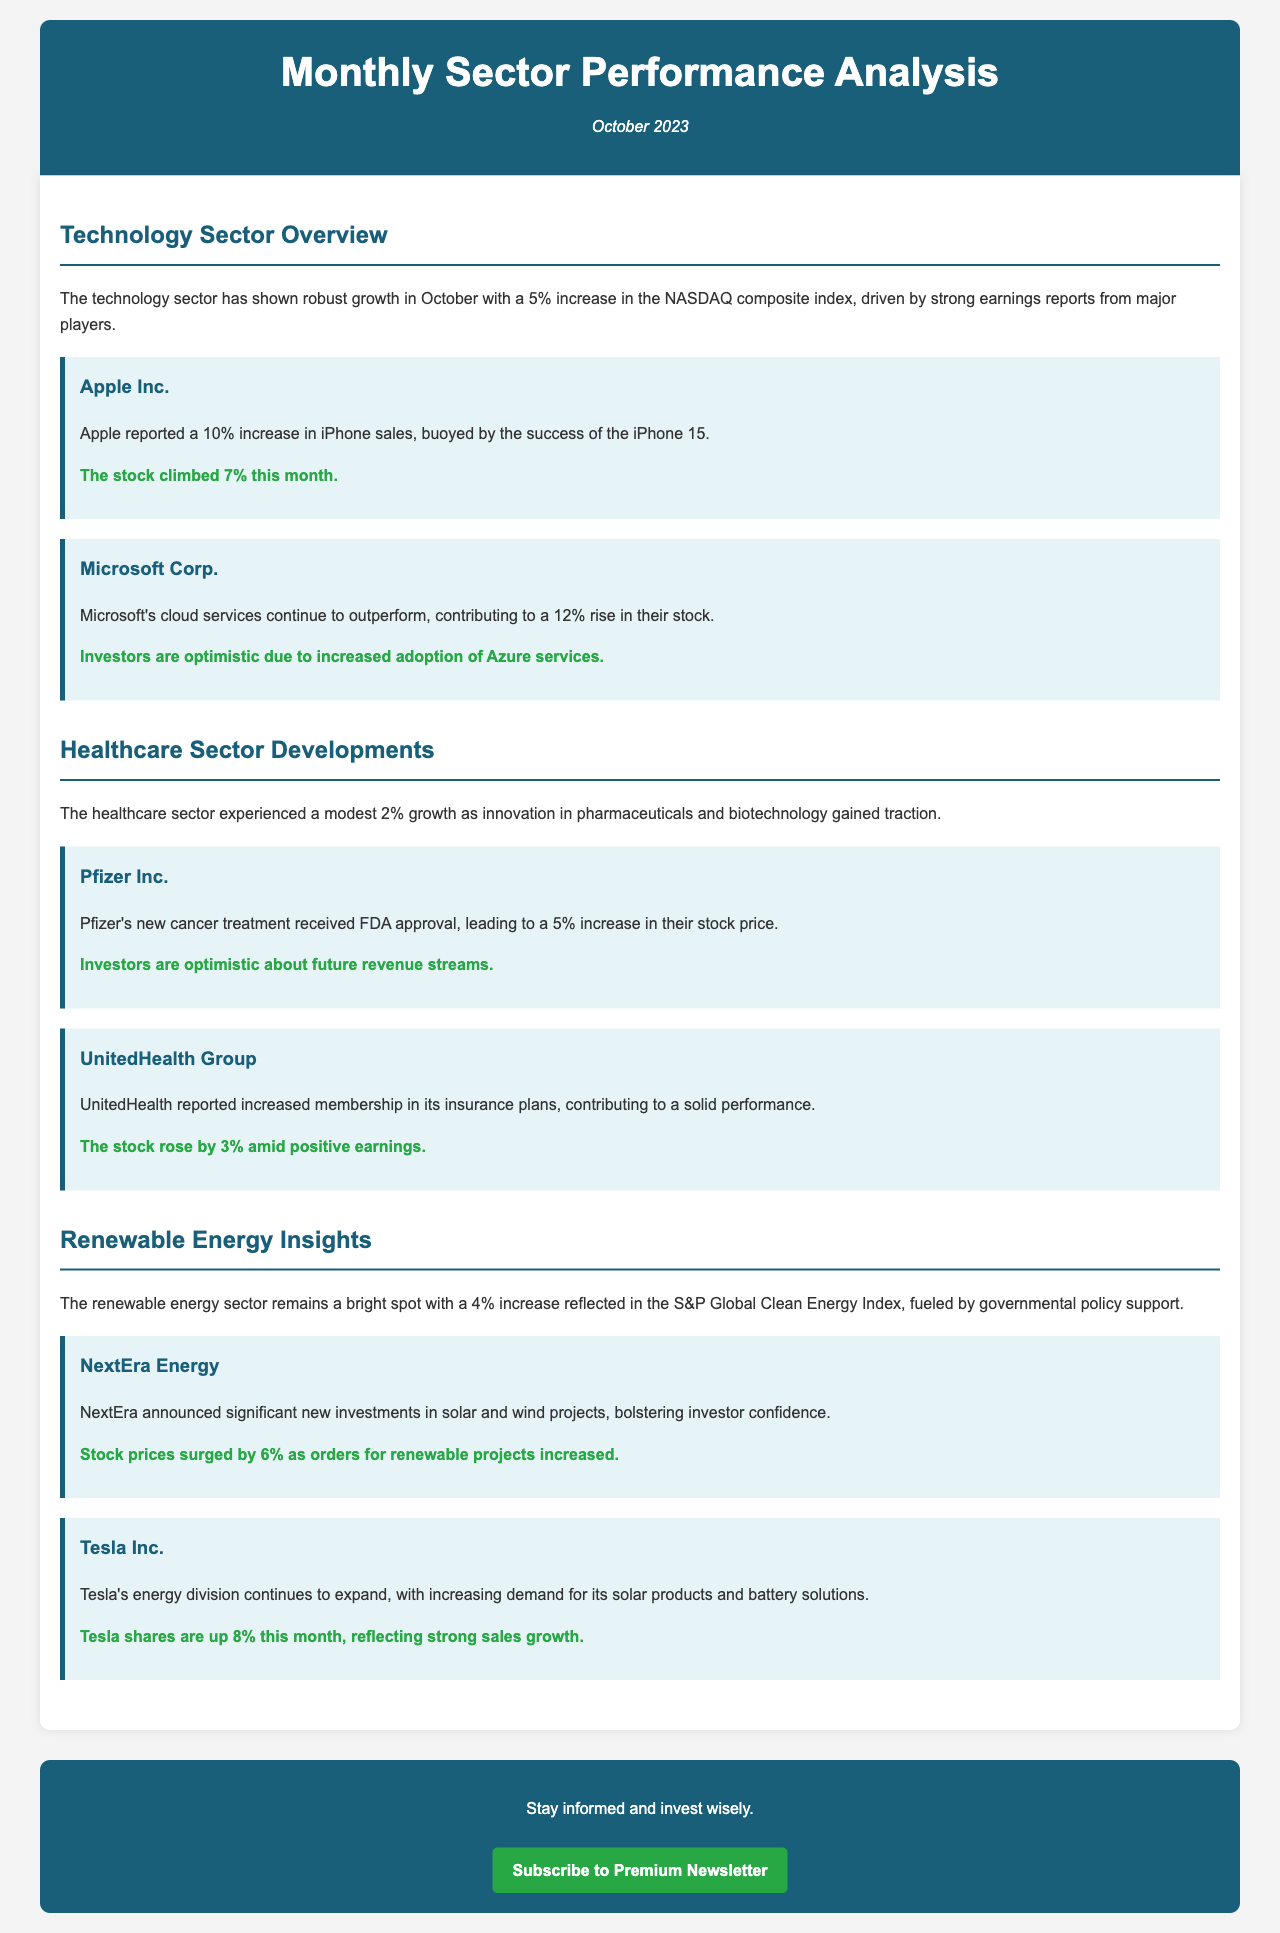What is the increase in the NASDAQ composite index for October? The document states that the technology sector saw a 5% increase in the NASDAQ composite index in October.
Answer: 5% Which company's stock rose by 7% this month? The newsletter indicates that Apple Inc.'s stock climbed 7% this month.
Answer: Apple Inc What percentage increase did Pfizer's stock experience? The document notes a 5% increase in Pfizer's stock price following FDA approval for a new treatment.
Answer: 5% What is NextEra Energy's stock price increase this month? The document highlights a 6% surge in stock prices for NextEra Energy.
Answer: 6% Which healthcare company reported increased membership in its insurance plans? The newsletter mentions that UnitedHealth Group reported increased membership in its insurance plans.
Answer: UnitedHealth Group What is the primary factor driving the growth in the renewable energy sector? The document points out that governmental policy support is fueling growth in the renewable energy sector.
Answer: Governmental policy support What was the increase in stock price for Microsoft? The document indicates that Microsoft’s stock rose by 12%.
Answer: 12% Which company announced significant new investments in solar and wind projects? The newsletter states that NextEra announced significant new investments in solar and wind projects.
Answer: NextEra How much did Tesla's shares increase this month? The document specifies that Tesla shares are up 8% this month.
Answer: 8% 